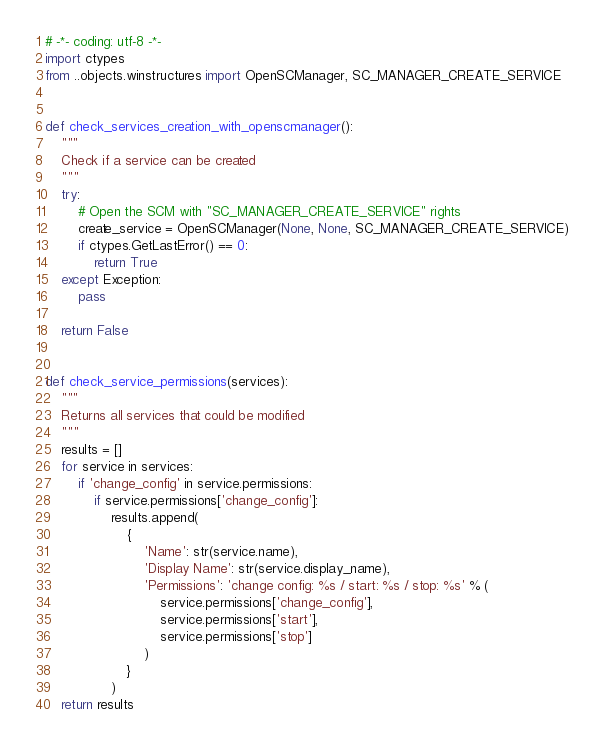<code> <loc_0><loc_0><loc_500><loc_500><_Python_># -*- coding: utf-8 -*-
import ctypes
from ..objects.winstructures import OpenSCManager, SC_MANAGER_CREATE_SERVICE


def check_services_creation_with_openscmanager():
    """
    Check if a service can be created
    """
    try:
        # Open the SCM with "SC_MANAGER_CREATE_SERVICE" rights
        create_service = OpenSCManager(None, None, SC_MANAGER_CREATE_SERVICE)
        if ctypes.GetLastError() == 0:
            return True
    except Exception:
        pass

    return False


def check_service_permissions(services):
    """
    Returns all services that could be modified
    """
    results = []
    for service in services:
        if 'change_config' in service.permissions:
            if service.permissions['change_config']:
                results.append(
                    {
                        'Name': str(service.name),
                        'Display Name': str(service.display_name),
                        'Permissions': 'change config: %s / start: %s / stop: %s' % (
                            service.permissions['change_config'],
                            service.permissions['start'],
                            service.permissions['stop']
                        )
                    }
                )
    return results
</code> 